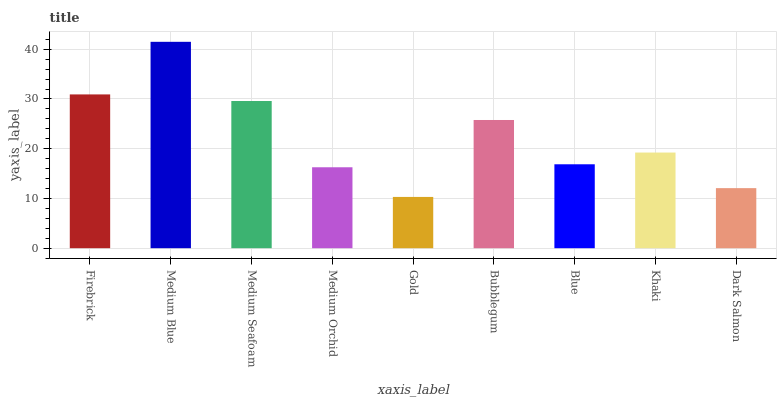Is Gold the minimum?
Answer yes or no. Yes. Is Medium Blue the maximum?
Answer yes or no. Yes. Is Medium Seafoam the minimum?
Answer yes or no. No. Is Medium Seafoam the maximum?
Answer yes or no. No. Is Medium Blue greater than Medium Seafoam?
Answer yes or no. Yes. Is Medium Seafoam less than Medium Blue?
Answer yes or no. Yes. Is Medium Seafoam greater than Medium Blue?
Answer yes or no. No. Is Medium Blue less than Medium Seafoam?
Answer yes or no. No. Is Khaki the high median?
Answer yes or no. Yes. Is Khaki the low median?
Answer yes or no. Yes. Is Medium Orchid the high median?
Answer yes or no. No. Is Firebrick the low median?
Answer yes or no. No. 